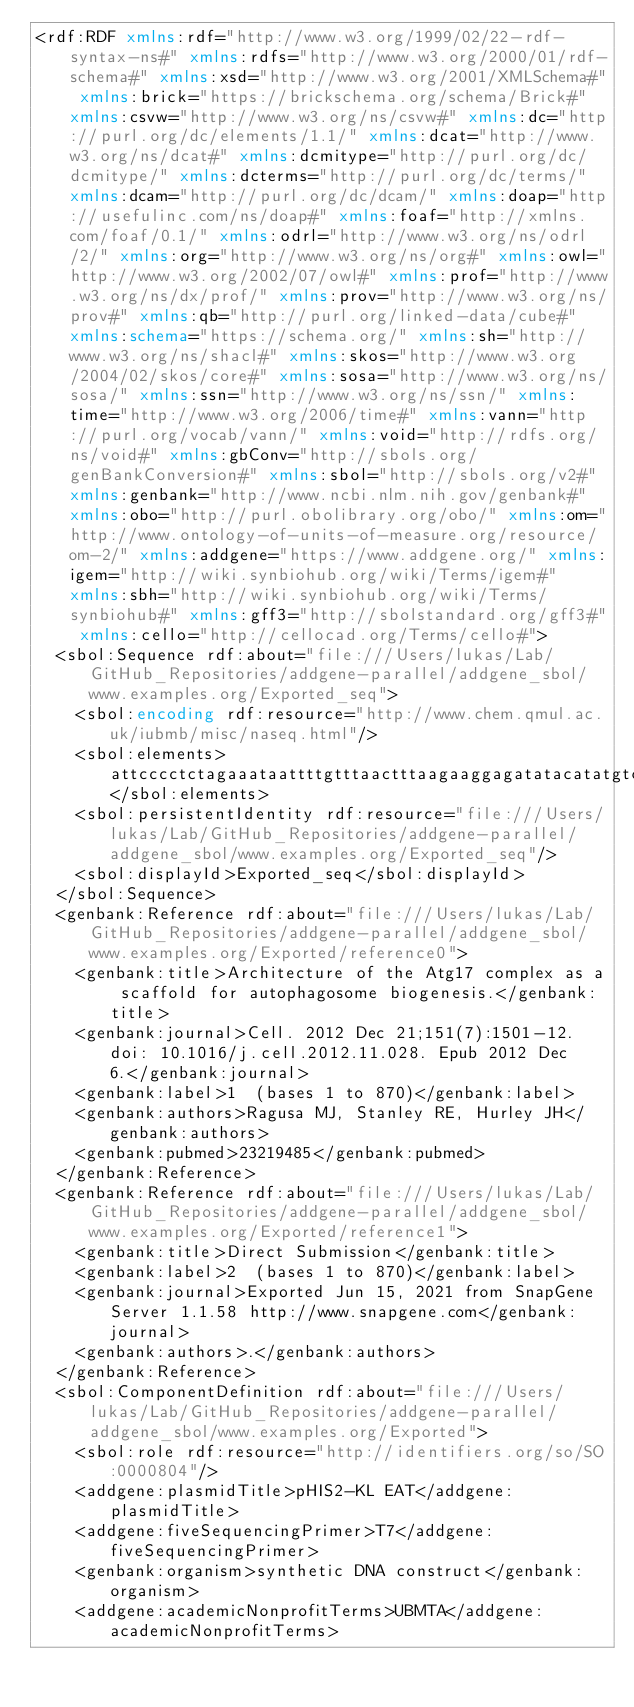<code> <loc_0><loc_0><loc_500><loc_500><_XML_><rdf:RDF xmlns:rdf="http://www.w3.org/1999/02/22-rdf-syntax-ns#" xmlns:rdfs="http://www.w3.org/2000/01/rdf-schema#" xmlns:xsd="http://www.w3.org/2001/XMLSchema#" xmlns:brick="https://brickschema.org/schema/Brick#" xmlns:csvw="http://www.w3.org/ns/csvw#" xmlns:dc="http://purl.org/dc/elements/1.1/" xmlns:dcat="http://www.w3.org/ns/dcat#" xmlns:dcmitype="http://purl.org/dc/dcmitype/" xmlns:dcterms="http://purl.org/dc/terms/" xmlns:dcam="http://purl.org/dc/dcam/" xmlns:doap="http://usefulinc.com/ns/doap#" xmlns:foaf="http://xmlns.com/foaf/0.1/" xmlns:odrl="http://www.w3.org/ns/odrl/2/" xmlns:org="http://www.w3.org/ns/org#" xmlns:owl="http://www.w3.org/2002/07/owl#" xmlns:prof="http://www.w3.org/ns/dx/prof/" xmlns:prov="http://www.w3.org/ns/prov#" xmlns:qb="http://purl.org/linked-data/cube#" xmlns:schema="https://schema.org/" xmlns:sh="http://www.w3.org/ns/shacl#" xmlns:skos="http://www.w3.org/2004/02/skos/core#" xmlns:sosa="http://www.w3.org/ns/sosa/" xmlns:ssn="http://www.w3.org/ns/ssn/" xmlns:time="http://www.w3.org/2006/time#" xmlns:vann="http://purl.org/vocab/vann/" xmlns:void="http://rdfs.org/ns/void#" xmlns:gbConv="http://sbols.org/genBankConversion#" xmlns:sbol="http://sbols.org/v2#" xmlns:genbank="http://www.ncbi.nlm.nih.gov/genbank#" xmlns:obo="http://purl.obolibrary.org/obo/" xmlns:om="http://www.ontology-of-units-of-measure.org/resource/om-2/" xmlns:addgene="https://www.addgene.org/" xmlns:igem="http://wiki.synbiohub.org/wiki/Terms/igem#" xmlns:sbh="http://wiki.synbiohub.org/wiki/Terms/synbiohub#" xmlns:gff3="http://sbolstandard.org/gff3#" xmlns:cello="http://cellocad.org/Terms/cello#">
  <sbol:Sequence rdf:about="file:///Users/lukas/Lab/GitHub_Repositories/addgene-parallel/addgene_sbol/www.examples.org/Exported_seq">
    <sbol:encoding rdf:resource="http://www.chem.qmul.ac.uk/iubmb/misc/naseq.html"/>
    <sbol:elements>attcccctctagaaataattttgtttaactttaagaaggagatatacatatgtcgtactaccatcaccatcaccatcacgattacgatatcccaacgaccgaaaacctgtattttcagggcgccatgggatccgattccaacataactcctgcagtggaatcgcttgcggccaaagcatttgtcatgtattcgttcgctgaaatgaaattctctcaaattcttccaactcctccttcttcaaccgactatgacccactgtcagataaacgtctaagtaacggaagttgcgcgatagaggatgaagaagatttggatcaaggccgcccaccttctaatcaaactttgacctcagcaacaacaaagatttcatcagccaccaatgttgacactcaaataccggcccccgagttgaaaaagttgtgcaccgaatctttacttctttatctaaaagctcttactattttagctgcttcaatgaaattaacatcaaaatggtggtatgaaaatgaaagtaaaaactgcactttgaagctaaacattttggtgcagtggattagagatcgctttaacgaatgcttagacaaggctgaatttttgcgtttaaagctccatgctattaatacatcaccaaattcccaatggtcagatgatgaccctgtaatttttgttgaaaagttaatatacgatcgtgctttagatatatctagaaatgctgcaagaatggaaatggaaagtgggaattacaatacttgtgaactagcctatgctacttcattatggatgttagaaattttgctggacgaaaattttcaattcaacgaagtctatgatgacgagtatgcatcaaatatcacctccttagacgaatc</sbol:elements>
    <sbol:persistentIdentity rdf:resource="file:///Users/lukas/Lab/GitHub_Repositories/addgene-parallel/addgene_sbol/www.examples.org/Exported_seq"/>
    <sbol:displayId>Exported_seq</sbol:displayId>
  </sbol:Sequence>
  <genbank:Reference rdf:about="file:///Users/lukas/Lab/GitHub_Repositories/addgene-parallel/addgene_sbol/www.examples.org/Exported/reference0">
    <genbank:title>Architecture of the Atg17 complex as a scaffold for autophagosome biogenesis.</genbank:title>
    <genbank:journal>Cell. 2012 Dec 21;151(7):1501-12. doi: 10.1016/j.cell.2012.11.028. Epub 2012 Dec 6.</genbank:journal>
    <genbank:label>1  (bases 1 to 870)</genbank:label>
    <genbank:authors>Ragusa MJ, Stanley RE, Hurley JH</genbank:authors>
    <genbank:pubmed>23219485</genbank:pubmed>
  </genbank:Reference>
  <genbank:Reference rdf:about="file:///Users/lukas/Lab/GitHub_Repositories/addgene-parallel/addgene_sbol/www.examples.org/Exported/reference1">
    <genbank:title>Direct Submission</genbank:title>
    <genbank:label>2  (bases 1 to 870)</genbank:label>
    <genbank:journal>Exported Jun 15, 2021 from SnapGene Server 1.1.58 http://www.snapgene.com</genbank:journal>
    <genbank:authors>.</genbank:authors>
  </genbank:Reference>
  <sbol:ComponentDefinition rdf:about="file:///Users/lukas/Lab/GitHub_Repositories/addgene-parallel/addgene_sbol/www.examples.org/Exported">
    <sbol:role rdf:resource="http://identifiers.org/so/SO:0000804"/>
    <addgene:plasmidTitle>pHIS2-KL EAT</addgene:plasmidTitle>
    <addgene:fiveSequencingPrimer>T7</addgene:fiveSequencingPrimer>
    <genbank:organism>synthetic DNA construct</genbank:organism>
    <addgene:academicNonprofitTerms>UBMTA</addgene:academicNonprofitTerms></code> 